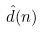<formula> <loc_0><loc_0><loc_500><loc_500>\hat { d } ( n )</formula> 